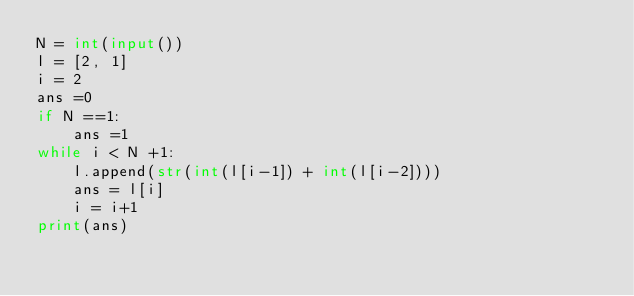<code> <loc_0><loc_0><loc_500><loc_500><_Python_>N = int(input())
l = [2, 1]
i = 2
ans =0
if N ==1:
    ans =1
while i < N +1:
    l.append(str(int(l[i-1]) + int(l[i-2])))
    ans = l[i]
    i = i+1
print(ans)</code> 